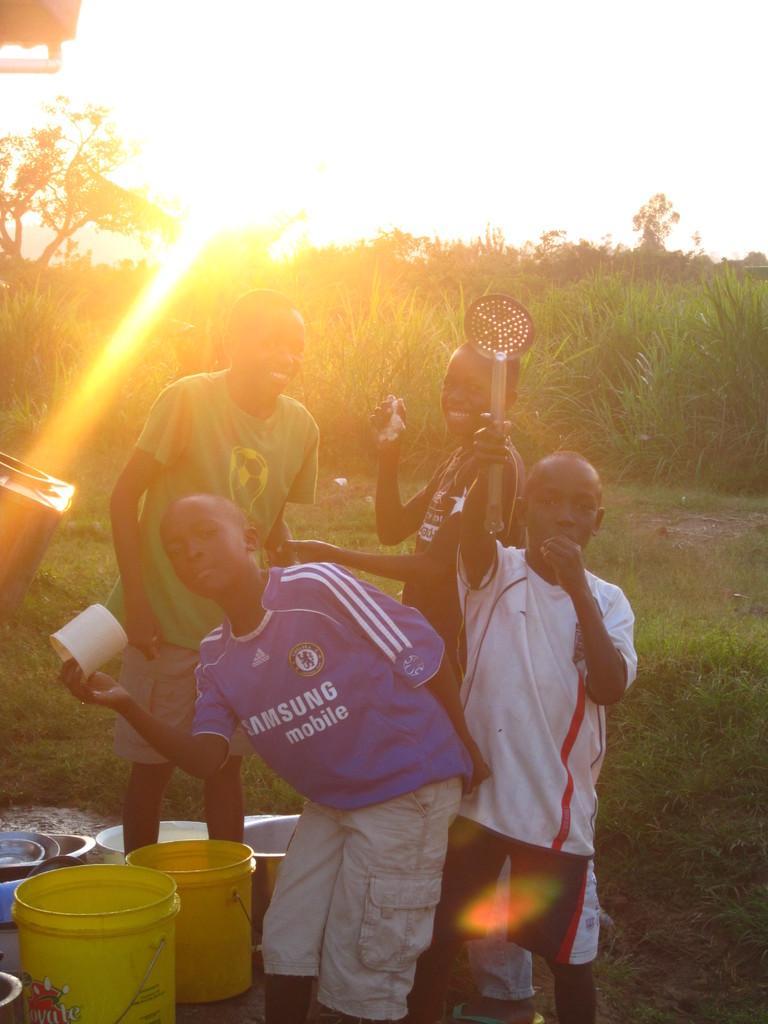Please provide a concise description of this image. In this image in the front there are persons standing and smiling and there are buckets and utensils on the ground. In the background there are trees and there's grass on the ground. 